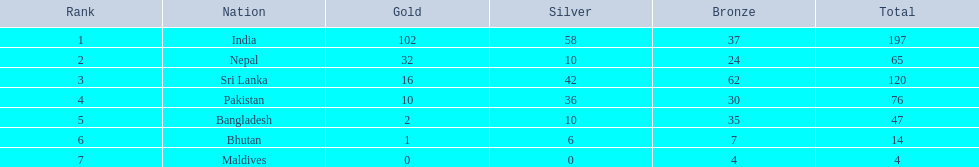In the 1999 south asian games, what were the participating countries? India, Nepal, Sri Lanka, Pakistan, Bangladesh, Bhutan, Maldives. Which one of them won 32 gold medals? Nepal. 